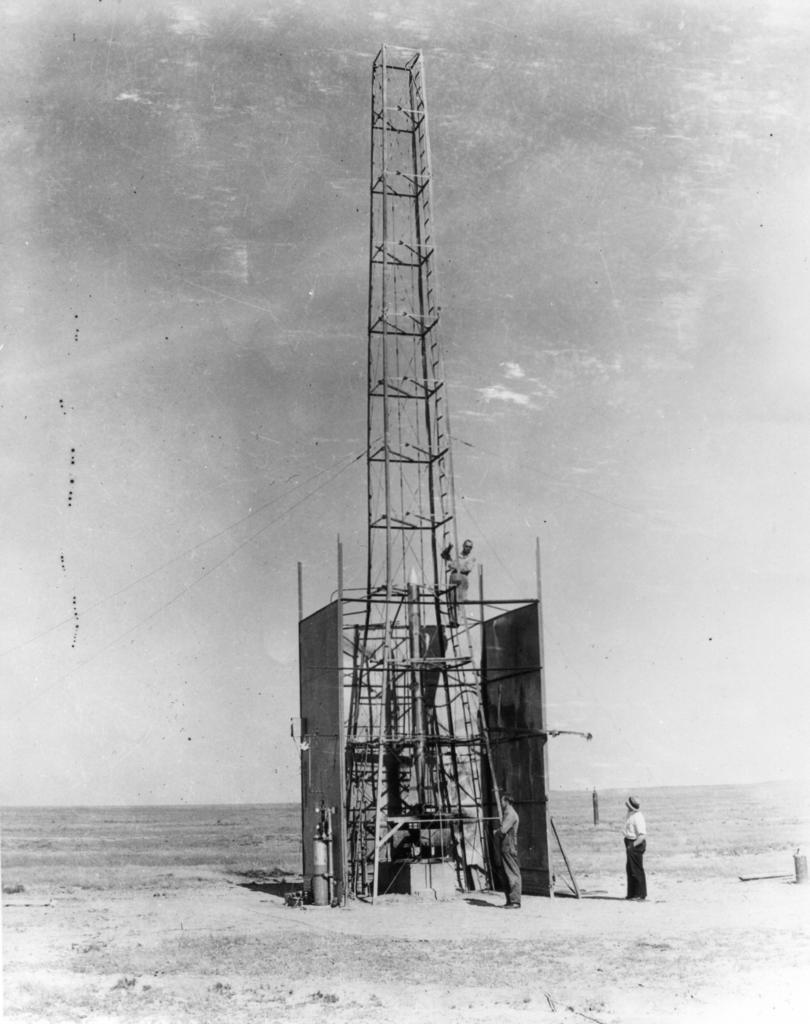What is the main structure in the middle of the image? There is a tower in the middle of the image. How many people are visible in the image? There are two persons standing on the ground. What is visible at the top of the image? The sky is visible at the top of the image. What is the color scheme of the image? The image is black and white. Can you see any bears or cats driving a car in the image? There are no bears, cats, or cars present in the image. 